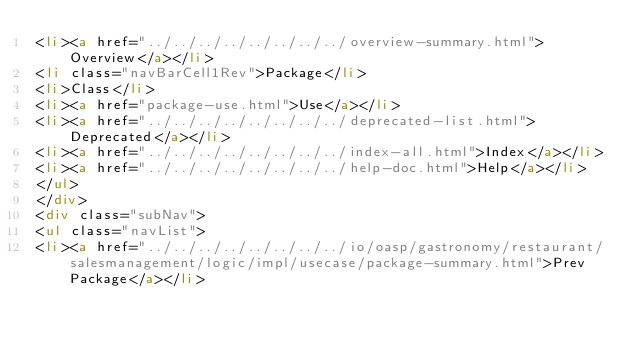Convert code to text. <code><loc_0><loc_0><loc_500><loc_500><_HTML_><li><a href="../../../../../../../../overview-summary.html">Overview</a></li>
<li class="navBarCell1Rev">Package</li>
<li>Class</li>
<li><a href="package-use.html">Use</a></li>
<li><a href="../../../../../../../../deprecated-list.html">Deprecated</a></li>
<li><a href="../../../../../../../../index-all.html">Index</a></li>
<li><a href="../../../../../../../../help-doc.html">Help</a></li>
</ul>
</div>
<div class="subNav">
<ul class="navList">
<li><a href="../../../../../../../../io/oasp/gastronomy/restaurant/salesmanagement/logic/impl/usecase/package-summary.html">Prev Package</a></li></code> 